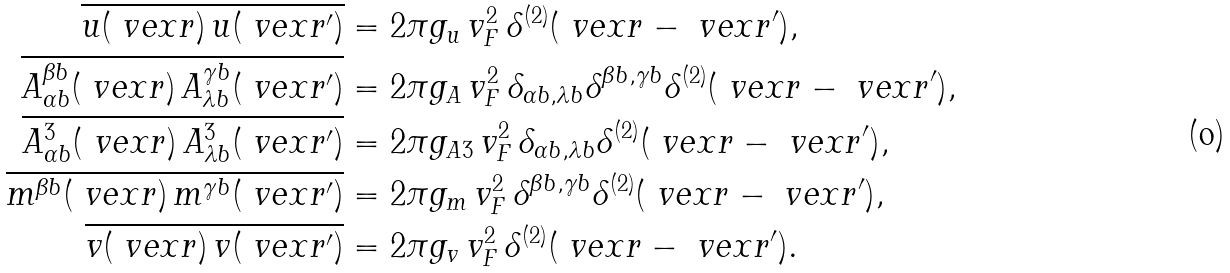Convert formula to latex. <formula><loc_0><loc_0><loc_500><loc_500>\overline { u ( \ v e x { r } ) \, u ( \ v e x { r ^ { \prime } } ) } & = 2 \pi g _ { u } \, v _ { F } ^ { 2 } \, \delta ^ { ( 2 ) } ( \ v e x { r } - \ v e x { r ^ { \prime } } ) , \\ \overline { A ^ { \beta b } _ { \alpha b } ( \ v e x { r } ) \, A ^ { \gamma b } _ { \lambda b } ( \ v e x { r ^ { \prime } } ) } & = 2 \pi g _ { A } \, v _ { F } ^ { 2 } \, \delta _ { \alpha b , \lambda b } \delta ^ { \beta b , \gamma b } \delta ^ { ( 2 ) } ( \ v e x { r } - \ v e x { r ^ { \prime } } ) , \\ \overline { A ^ { 3 } _ { \alpha b } ( \ v e x { r } ) \, A ^ { 3 } _ { \lambda b } ( \ v e x { r ^ { \prime } } ) } & = 2 \pi g _ { A 3 } \, v _ { F } ^ { 2 } \, \delta _ { \alpha b , \lambda b } \delta ^ { ( 2 ) } ( \ v e x { r } - \ v e x { r ^ { \prime } } ) , \\ \overline { m ^ { \beta b } ( \ v e x { r } ) \, m ^ { \gamma b } ( \ v e x { r ^ { \prime } } ) } & = 2 \pi g _ { m } \, v _ { F } ^ { 2 } \, \delta ^ { \beta b , \gamma b } \delta ^ { ( 2 ) } ( \ v e x { r } - \ v e x { r ^ { \prime } } ) , \\ \overline { v ( \ v e x { r } ) \, v ( \ v e x { r ^ { \prime } } ) } & = 2 \pi g _ { v } \, v _ { F } ^ { 2 } \, \delta ^ { ( 2 ) } ( \ v e x { r } - \ v e x { r ^ { \prime } } ) .</formula> 